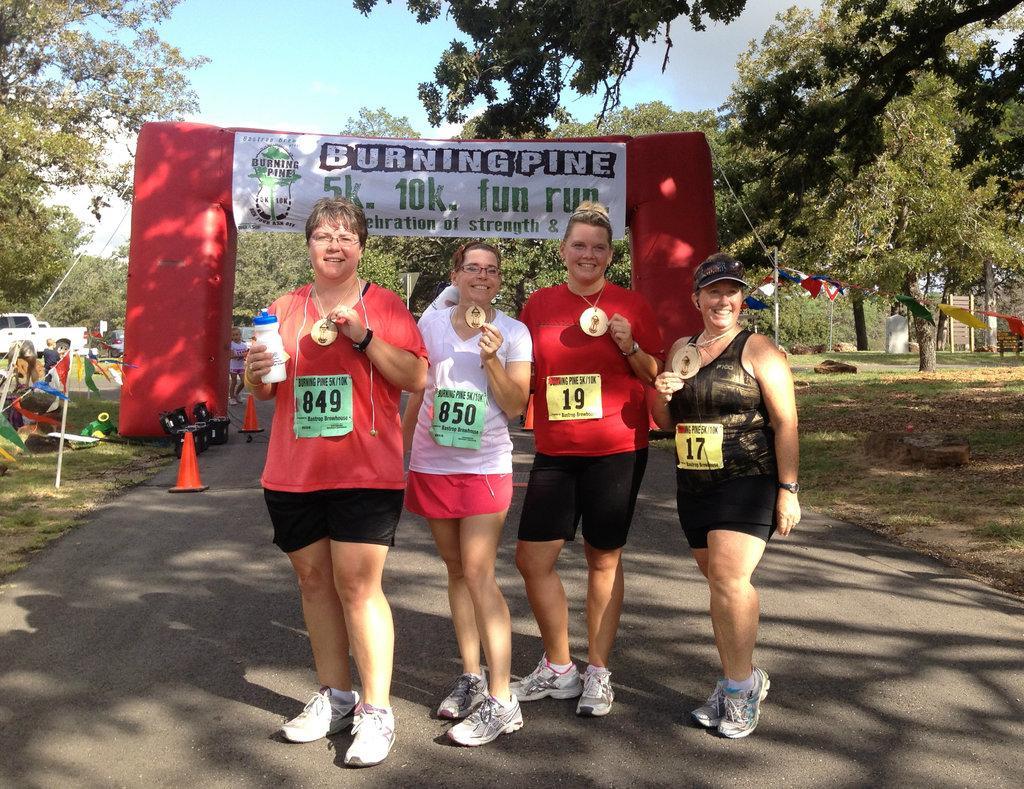Please provide a concise description of this image. In the middle of the image few women are standing on the road and smiling. Behind them there is a banner. Top of the image there are some trees. Behind the trees there is sky. Bottom left side of the image there are some poles and vehicles. 